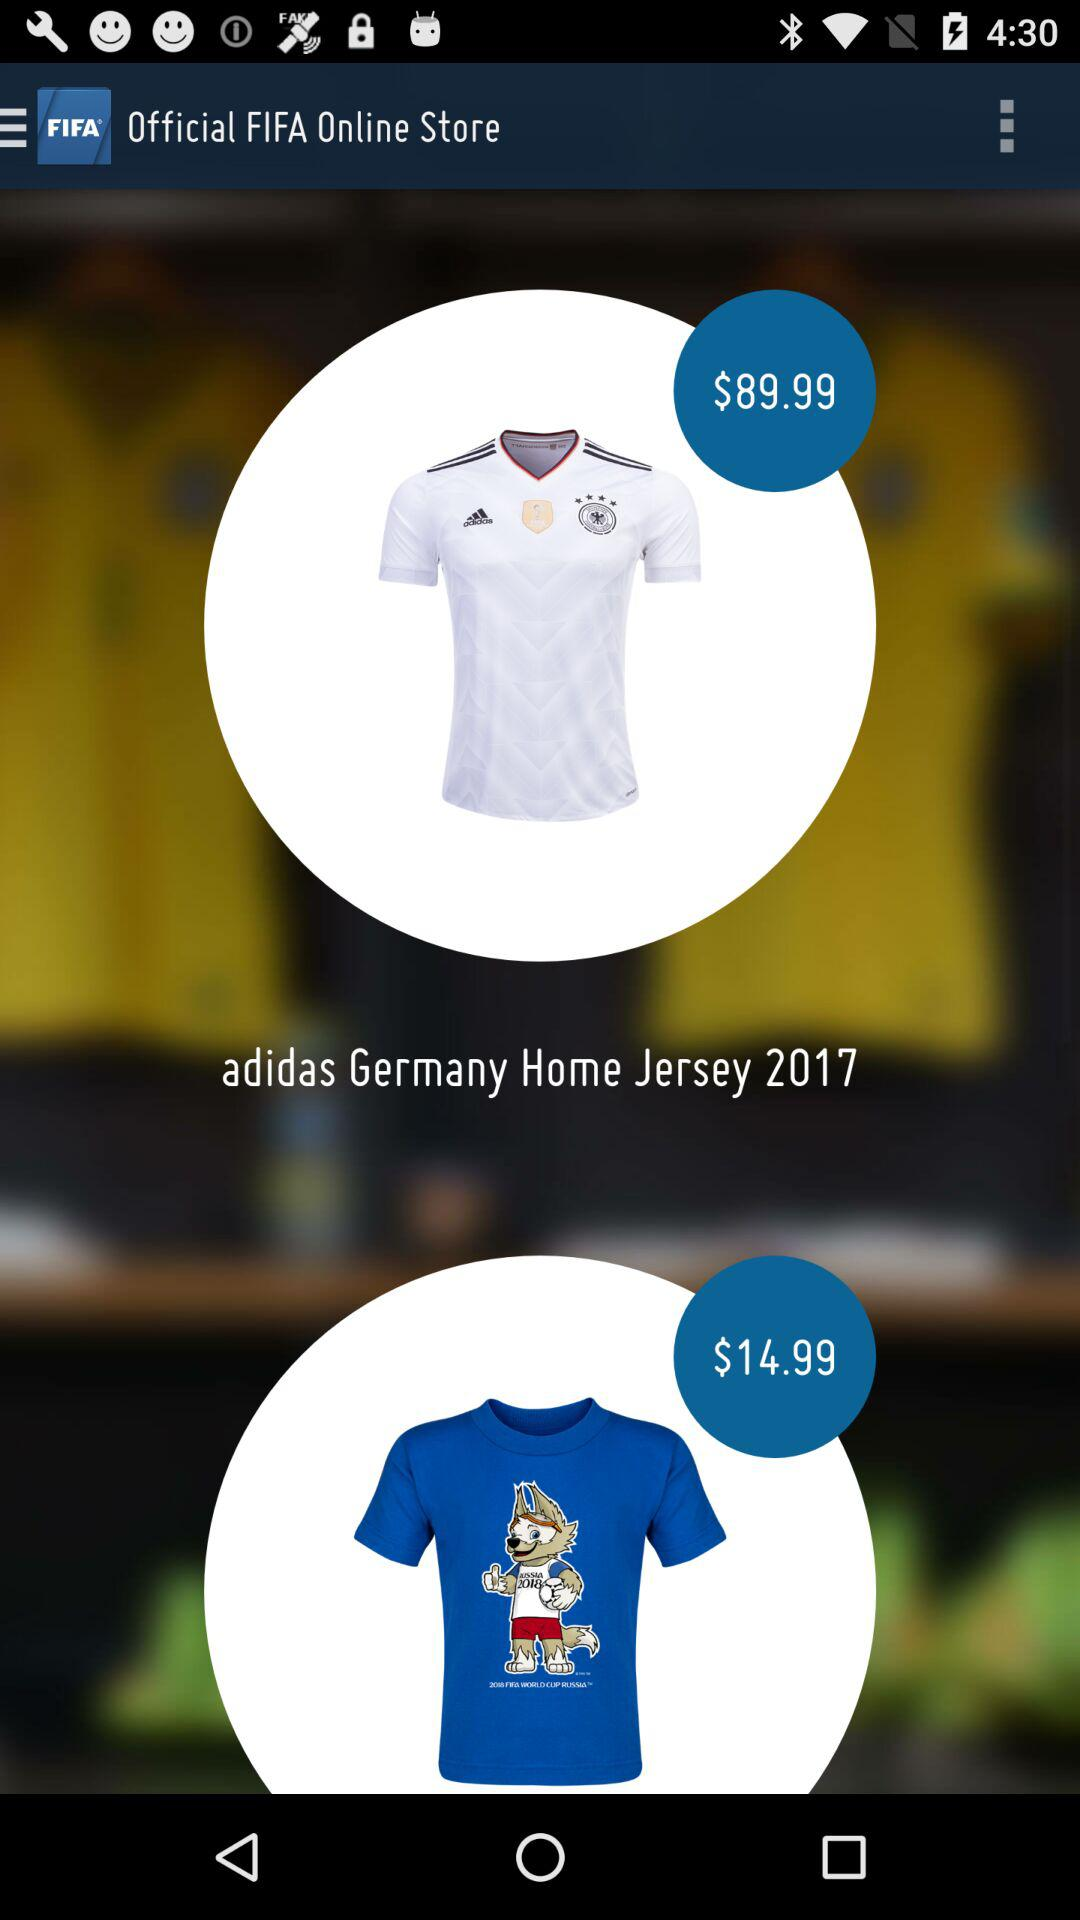How much more does the soccer jersey cost than the blue t-shirt?
Answer the question using a single word or phrase. $75.00 